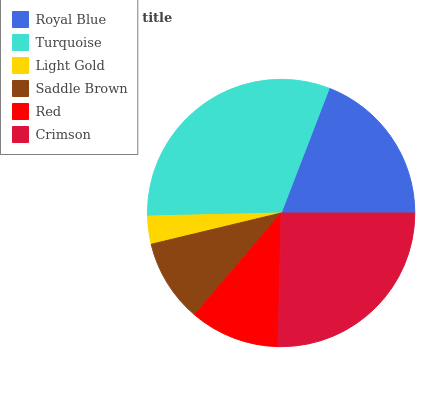Is Light Gold the minimum?
Answer yes or no. Yes. Is Turquoise the maximum?
Answer yes or no. Yes. Is Turquoise the minimum?
Answer yes or no. No. Is Light Gold the maximum?
Answer yes or no. No. Is Turquoise greater than Light Gold?
Answer yes or no. Yes. Is Light Gold less than Turquoise?
Answer yes or no. Yes. Is Light Gold greater than Turquoise?
Answer yes or no. No. Is Turquoise less than Light Gold?
Answer yes or no. No. Is Royal Blue the high median?
Answer yes or no. Yes. Is Red the low median?
Answer yes or no. Yes. Is Light Gold the high median?
Answer yes or no. No. Is Saddle Brown the low median?
Answer yes or no. No. 